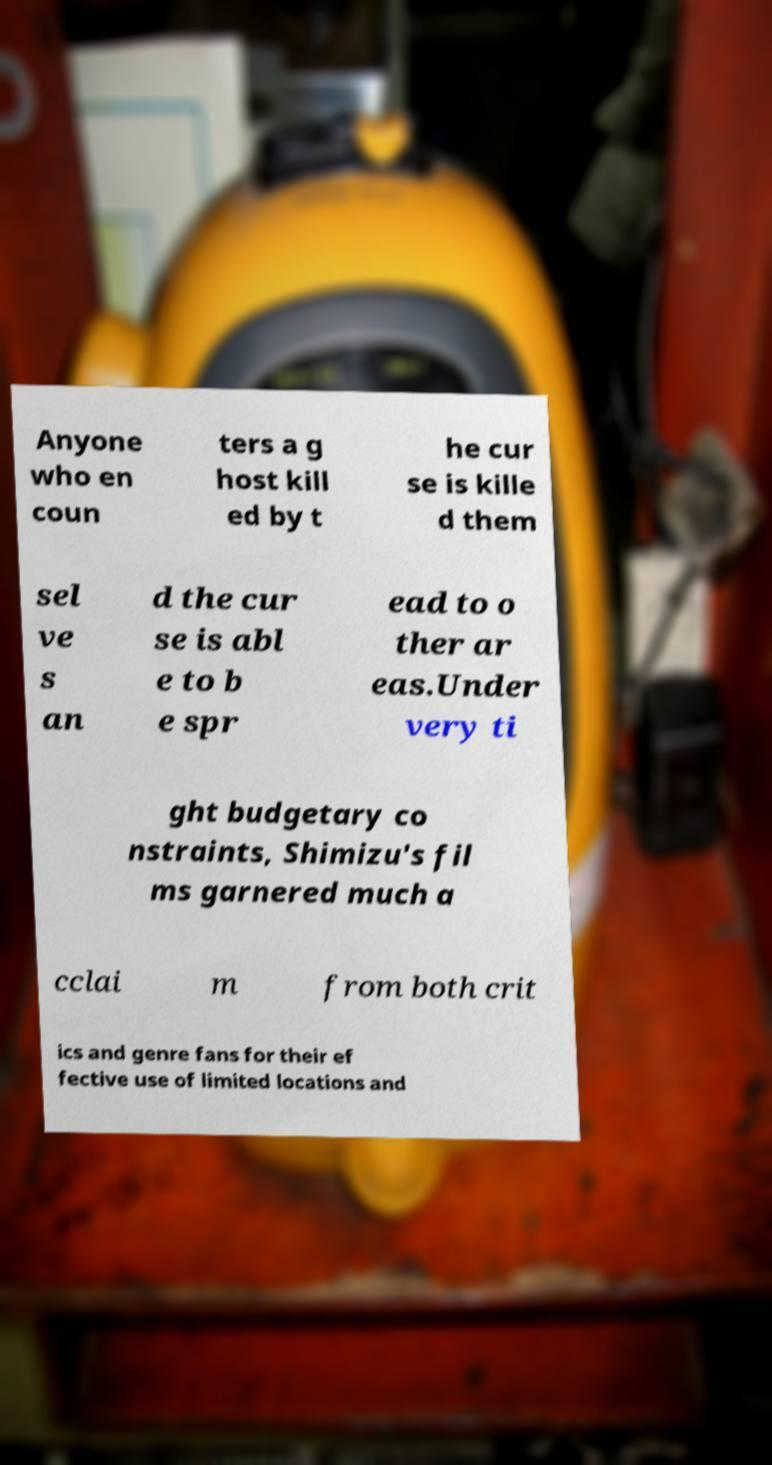Please read and relay the text visible in this image. What does it say? Anyone who en coun ters a g host kill ed by t he cur se is kille d them sel ve s an d the cur se is abl e to b e spr ead to o ther ar eas.Under very ti ght budgetary co nstraints, Shimizu's fil ms garnered much a cclai m from both crit ics and genre fans for their ef fective use of limited locations and 